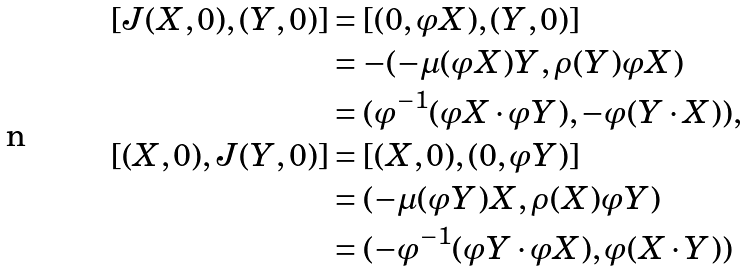<formula> <loc_0><loc_0><loc_500><loc_500>[ J ( X , 0 ) , ( Y , 0 ) ] & = [ ( 0 , \varphi X ) , ( Y , 0 ) ] \\ & = - ( - \mu ( \varphi X ) Y , \rho ( Y ) \varphi X ) \\ & = ( \varphi ^ { - 1 } ( \varphi X \cdot \varphi Y ) , - \varphi ( Y \cdot X ) ) , \\ [ ( X , 0 ) , J ( Y , 0 ) ] & = [ ( X , 0 ) , ( 0 , \varphi Y ) ] \\ & = ( - \mu ( \varphi Y ) X , \rho ( X ) \varphi Y ) \\ & = ( - \varphi ^ { - 1 } ( \varphi Y \cdot \varphi X ) , \varphi ( X \cdot Y ) )</formula> 